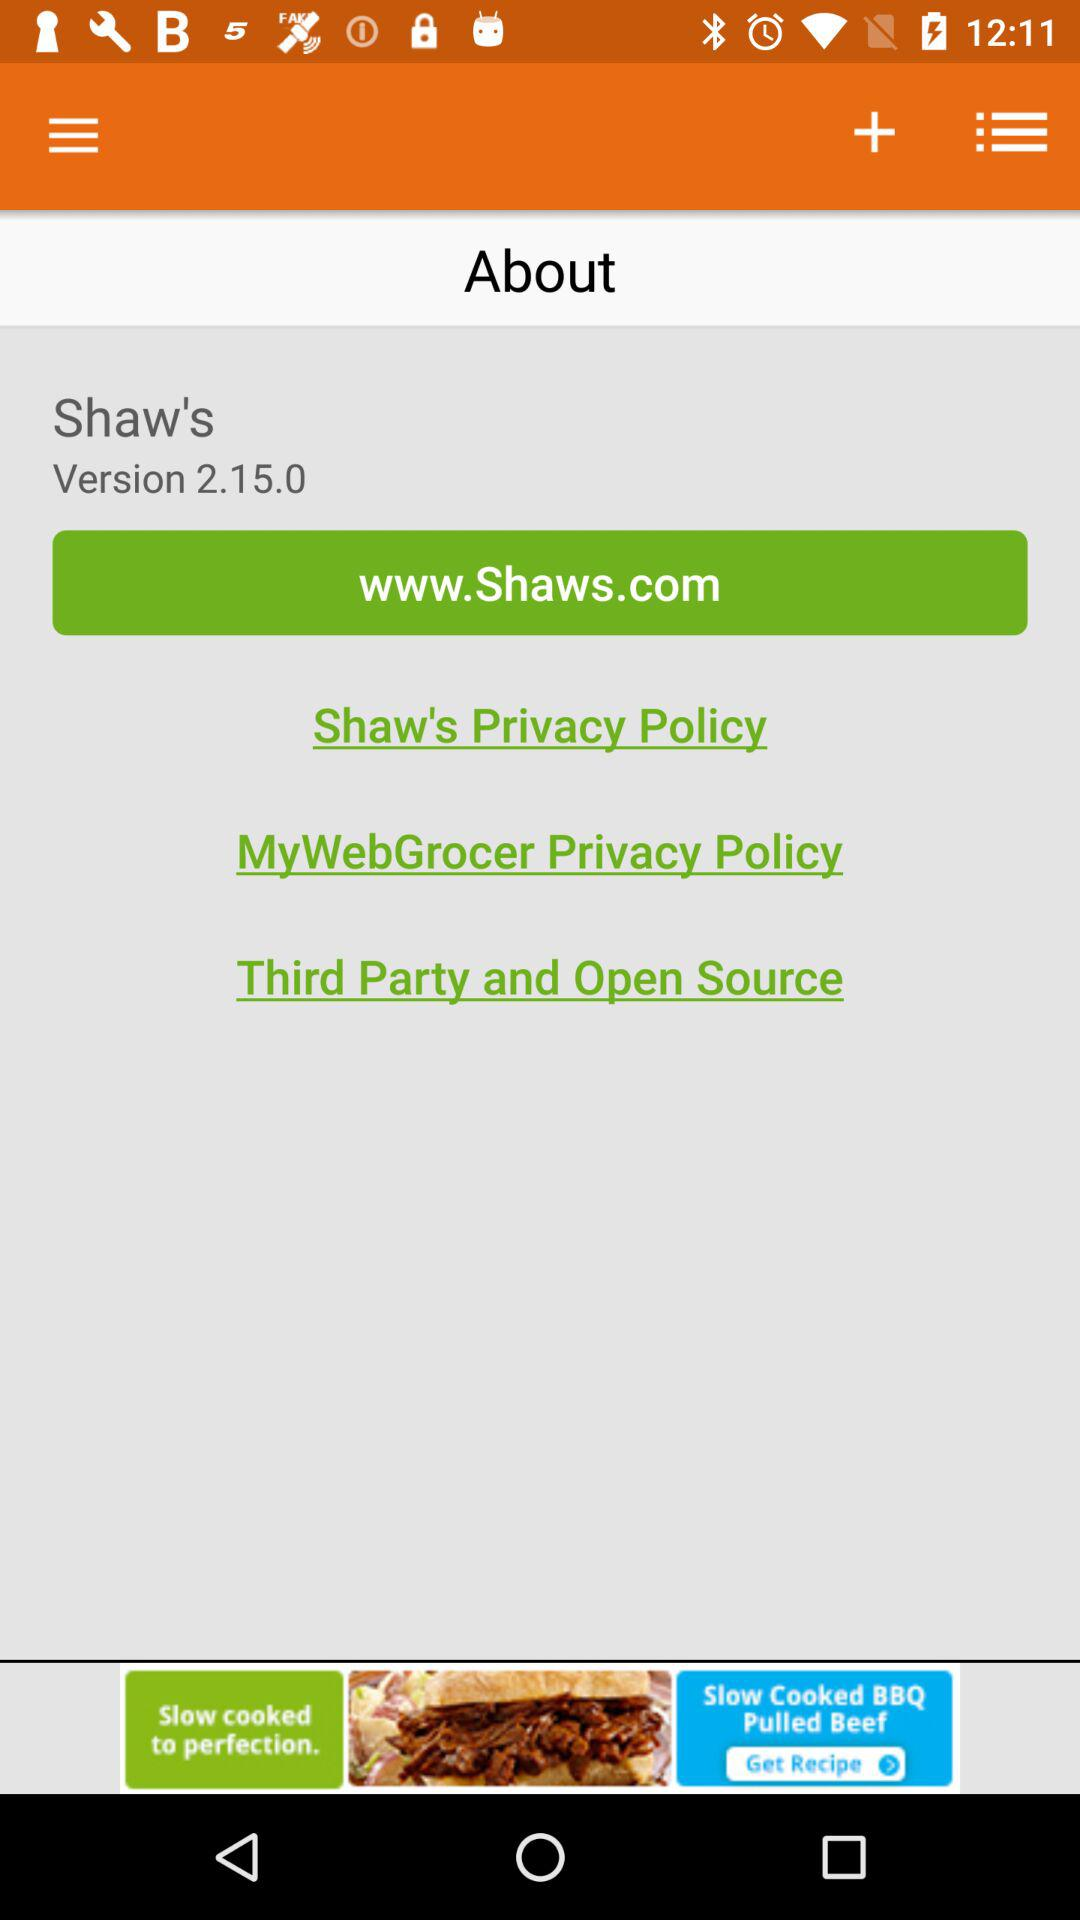What is the version of Shaw's? The version is 2.15.0. 